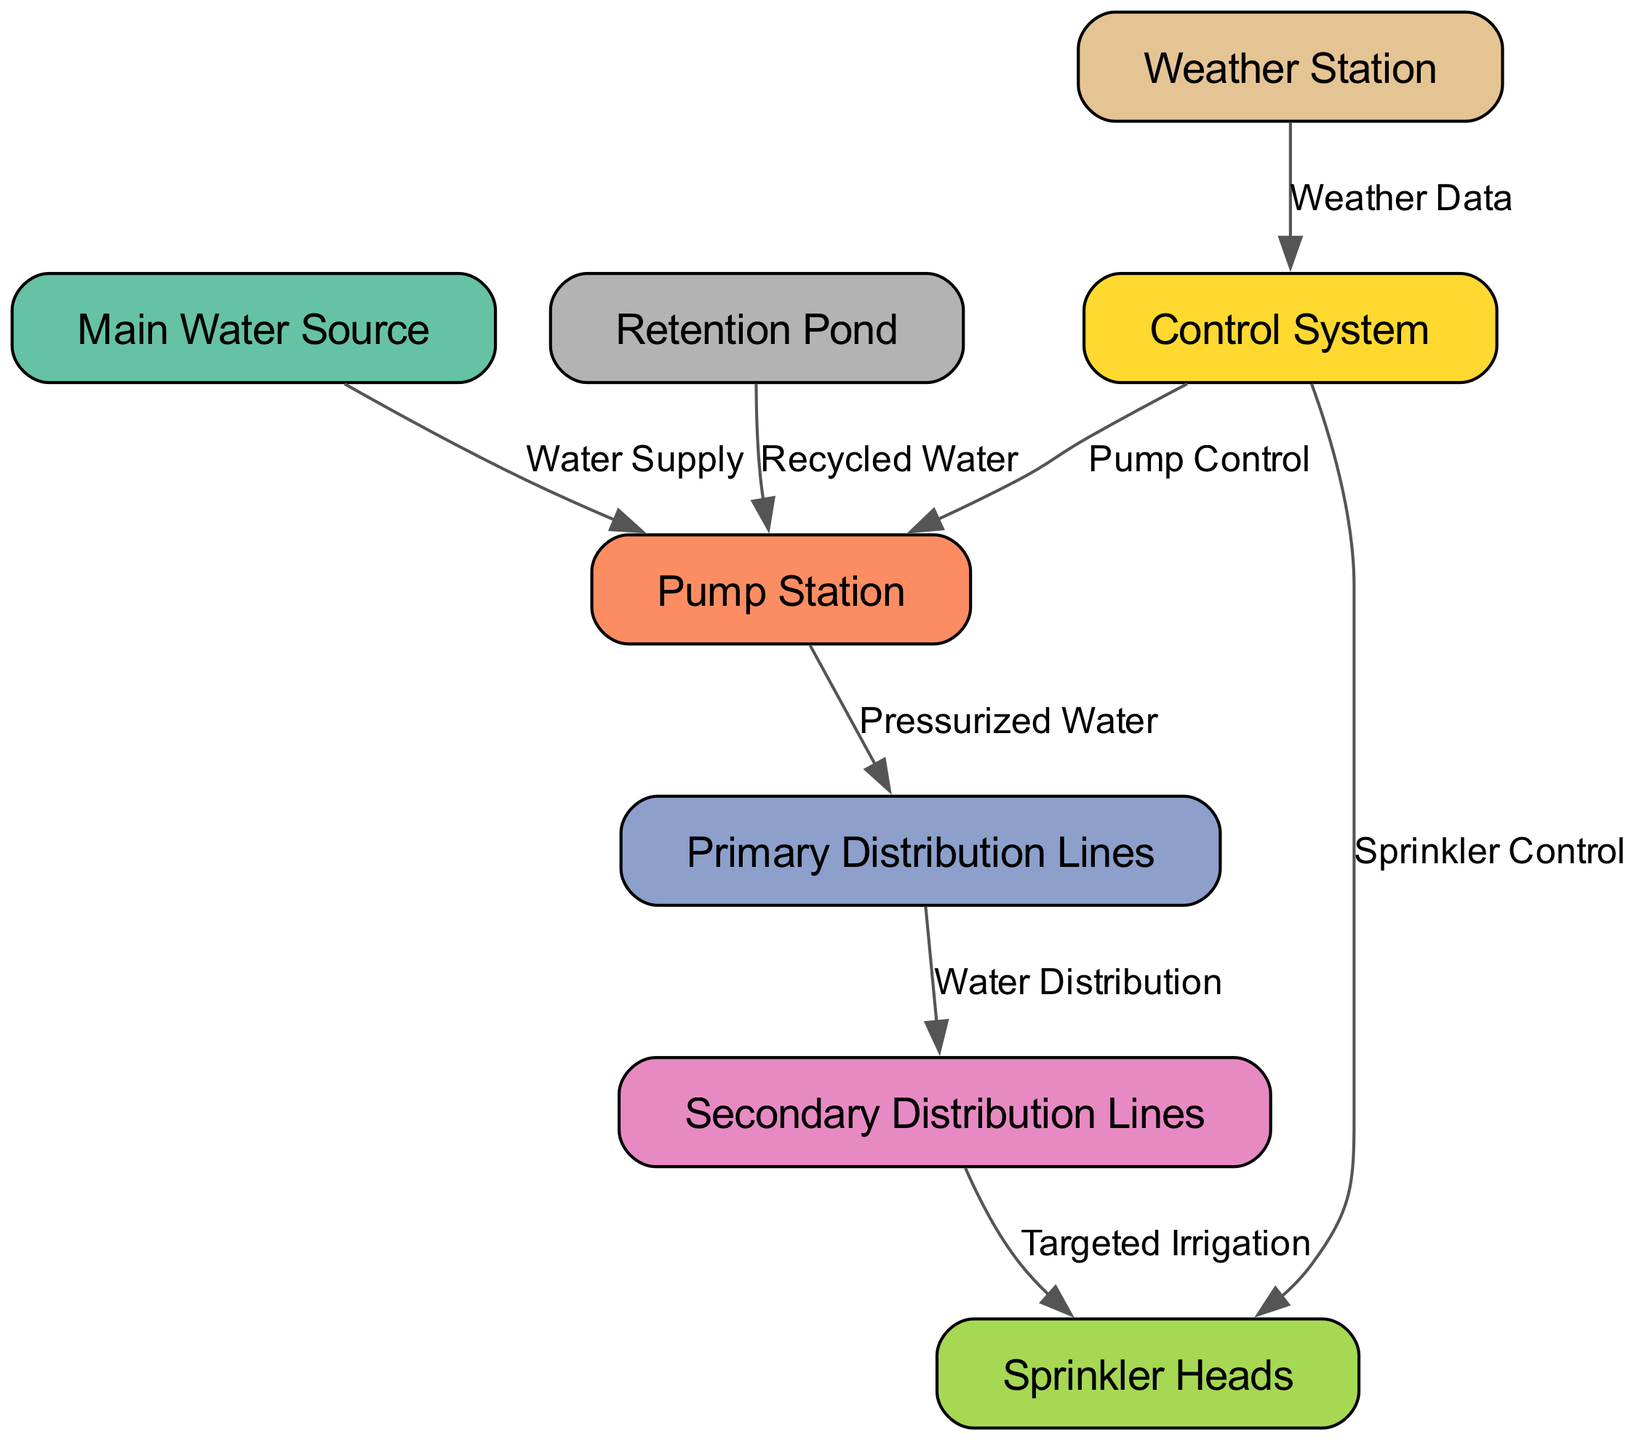What is the main source of water for the irrigation system? The diagram indicates that the 'Main Water Source' provides the primary supply. This is confirmed by the edge labeled 'Water Supply' connecting 'Main Water Source' to 'Pump Station'.
Answer: Main Water Source How many nodes are there in the irrigation system layout? Counting the entries listed under 'nodes', there are 8 distinct nodes representing various components in the irrigation system, such as the pump station and sprinkler heads.
Answer: 8 What type of control does the 'Control System' provide to the 'Sprinkler Heads'? The diagram shows a direct connection from 'Control System' to 'Sprinkler Heads' labeled 'Sprinkler Control', indicating that the control system manages sprinkler operations directly.
Answer: Sprinkler Control What is the purpose of the 'Weather Station' in this layout? The 'Weather Station' provides data to the 'Control System' as indicated by the edge labeled 'Weather Data', implying it is used for monitoring conditions to optimize irrigation controls.
Answer: Weather Data Which nodes are connected by the edge labeled 'Pressurized Water'? The edge labeled 'Pressurized Water' connects the 'Pump Station' to the 'Primary Distribution Lines', illustrating the flow of pressurized water produced by the pump for distribution.
Answer: Pump Station, Primary Distribution Lines How does the irrigation system utilize recycled water? The 'Retention Pond' contributes to the 'Pump Station' through an edge labeled 'Recycled Water', indicating that it supplies recycled water to the pump for processing and distribution.
Answer: Recycled Water What is the relationship between the 'Primary Distribution Lines' and the 'Secondary Distribution Lines'? The connection between 'Primary Distribution Lines' and 'Secondary Distribution Lines' is denoted by the edge labeled 'Water Distribution', indicating a tiered water distribution structure for irrigation.
Answer: Water Distribution How many edges are there in the diagram? By reviewing the 'edges' section, we count 8 edges that illustrate relationships between the various nodes, such as water supply lines and control connections.
Answer: 8 